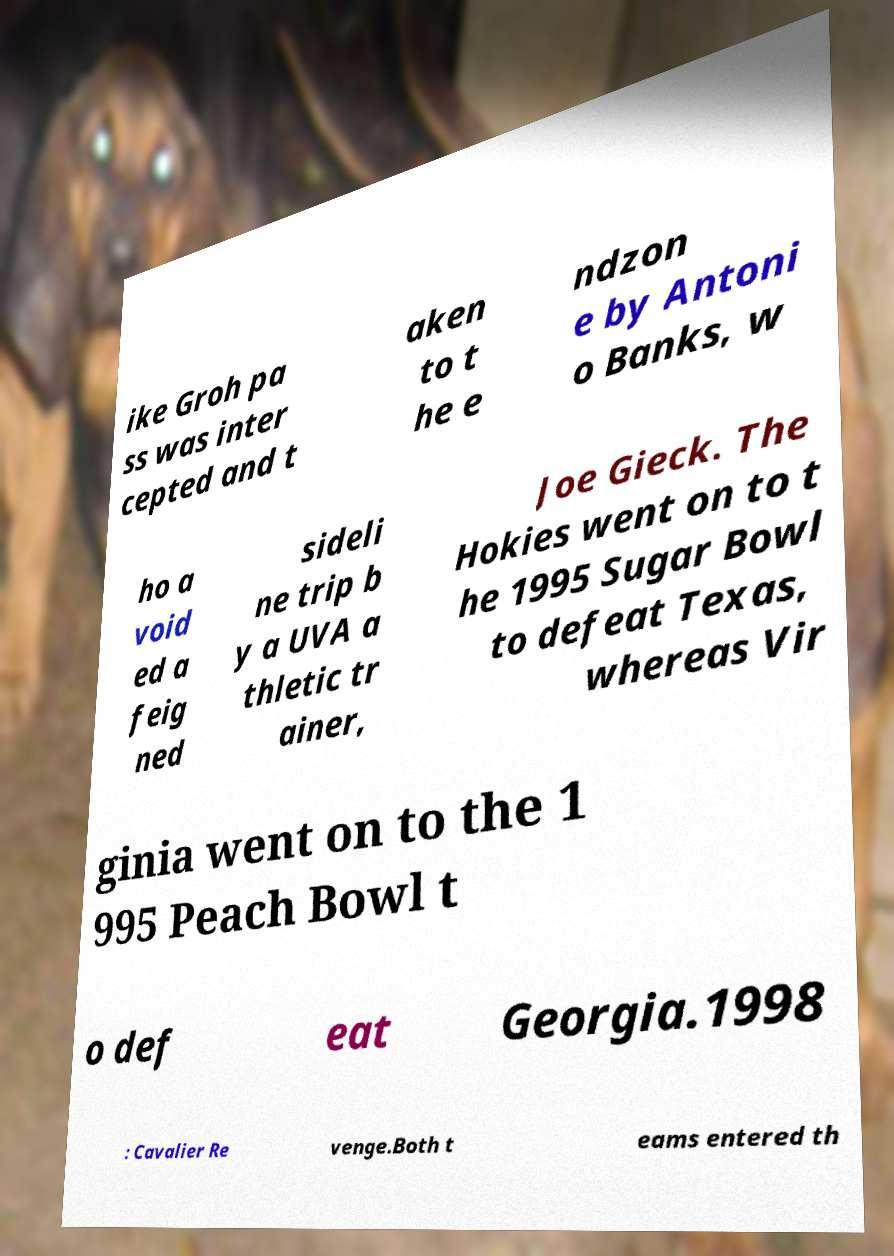Could you extract and type out the text from this image? ike Groh pa ss was inter cepted and t aken to t he e ndzon e by Antoni o Banks, w ho a void ed a feig ned sideli ne trip b y a UVA a thletic tr ainer, Joe Gieck. The Hokies went on to t he 1995 Sugar Bowl to defeat Texas, whereas Vir ginia went on to the 1 995 Peach Bowl t o def eat Georgia.1998 : Cavalier Re venge.Both t eams entered th 